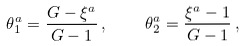<formula> <loc_0><loc_0><loc_500><loc_500>\theta ^ { a } _ { 1 } = \frac { G - \xi ^ { a } } { G - 1 } \, , \quad \theta ^ { a } _ { 2 } = \frac { \xi ^ { a } - 1 } { G - 1 } \, ,</formula> 